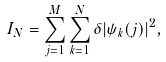<formula> <loc_0><loc_0><loc_500><loc_500>I _ { N } = \sum _ { j = 1 } ^ { M } \sum _ { k = 1 } ^ { N } \delta | \psi _ { k } ( j ) | ^ { 2 } ,</formula> 